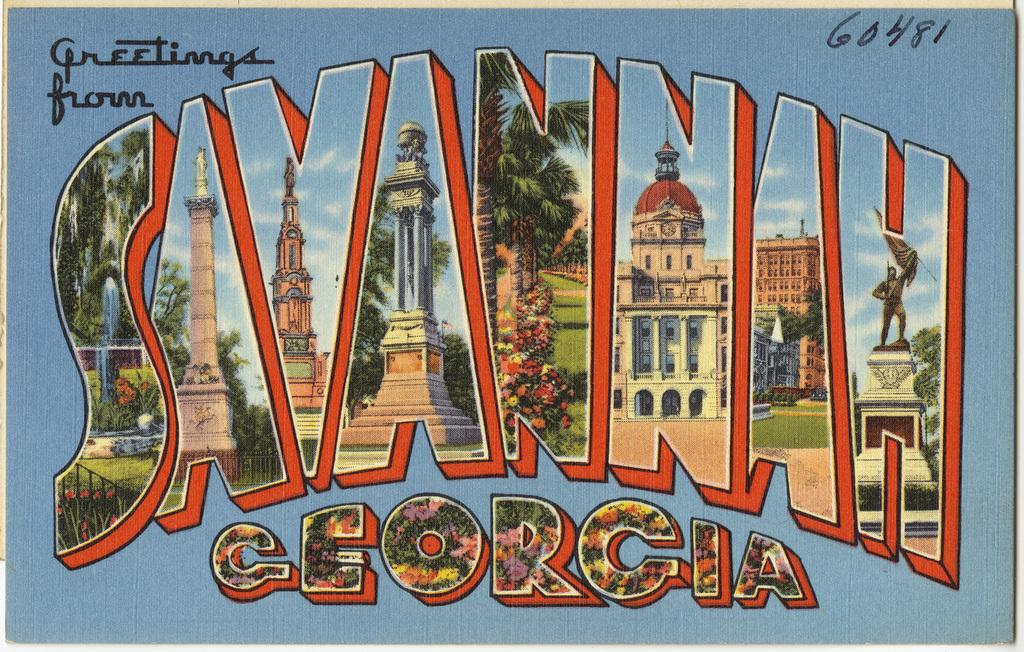<image>
Give a short and clear explanation of the subsequent image. blue postcard that states greetings from savannah georgia 